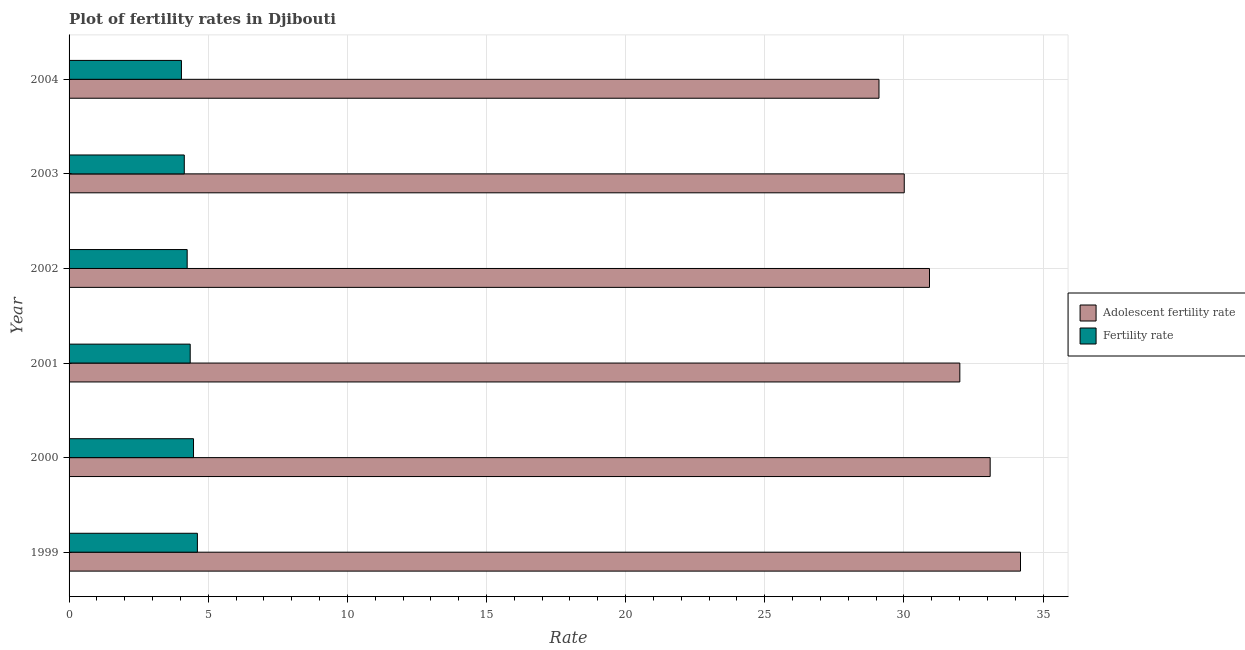How many groups of bars are there?
Keep it short and to the point. 6. Are the number of bars on each tick of the Y-axis equal?
Your answer should be compact. Yes. How many bars are there on the 6th tick from the top?
Provide a succinct answer. 2. In how many cases, is the number of bars for a given year not equal to the number of legend labels?
Offer a very short reply. 0. What is the adolescent fertility rate in 2001?
Ensure brevity in your answer.  32.01. Across all years, what is the maximum adolescent fertility rate?
Offer a terse response. 34.19. Across all years, what is the minimum fertility rate?
Your answer should be very brief. 4.04. What is the total adolescent fertility rate in the graph?
Ensure brevity in your answer.  189.33. What is the difference between the adolescent fertility rate in 2003 and that in 2004?
Offer a very short reply. 0.91. What is the difference between the adolescent fertility rate in 2002 and the fertility rate in 2003?
Your answer should be compact. 26.78. What is the average fertility rate per year?
Provide a succinct answer. 4.31. In the year 2000, what is the difference between the fertility rate and adolescent fertility rate?
Your response must be concise. -28.63. In how many years, is the fertility rate greater than 18 ?
Keep it short and to the point. 0. What is the ratio of the adolescent fertility rate in 1999 to that in 2004?
Offer a terse response. 1.18. Is the adolescent fertility rate in 2000 less than that in 2002?
Offer a terse response. No. Is the difference between the fertility rate in 2001 and 2003 greater than the difference between the adolescent fertility rate in 2001 and 2003?
Make the answer very short. No. What is the difference between the highest and the second highest adolescent fertility rate?
Provide a succinct answer. 1.09. What is the difference between the highest and the lowest adolescent fertility rate?
Offer a terse response. 5.09. In how many years, is the fertility rate greater than the average fertility rate taken over all years?
Keep it short and to the point. 3. What does the 1st bar from the top in 2000 represents?
Keep it short and to the point. Fertility rate. What does the 1st bar from the bottom in 2004 represents?
Keep it short and to the point. Adolescent fertility rate. Are all the bars in the graph horizontal?
Offer a terse response. Yes. What is the difference between two consecutive major ticks on the X-axis?
Offer a terse response. 5. Are the values on the major ticks of X-axis written in scientific E-notation?
Provide a succinct answer. No. Does the graph contain any zero values?
Your answer should be very brief. No. How are the legend labels stacked?
Provide a short and direct response. Vertical. What is the title of the graph?
Provide a short and direct response. Plot of fertility rates in Djibouti. Does "Male" appear as one of the legend labels in the graph?
Provide a short and direct response. No. What is the label or title of the X-axis?
Provide a succinct answer. Rate. What is the label or title of the Y-axis?
Keep it short and to the point. Year. What is the Rate of Adolescent fertility rate in 1999?
Your answer should be compact. 34.19. What is the Rate in Fertility rate in 1999?
Give a very brief answer. 4.61. What is the Rate of Adolescent fertility rate in 2000?
Your response must be concise. 33.1. What is the Rate of Fertility rate in 2000?
Make the answer very short. 4.47. What is the Rate in Adolescent fertility rate in 2001?
Offer a very short reply. 32.01. What is the Rate of Fertility rate in 2001?
Your answer should be very brief. 4.35. What is the Rate of Adolescent fertility rate in 2002?
Make the answer very short. 30.92. What is the Rate of Fertility rate in 2002?
Your response must be concise. 4.24. What is the Rate of Adolescent fertility rate in 2003?
Provide a short and direct response. 30.01. What is the Rate in Fertility rate in 2003?
Offer a terse response. 4.14. What is the Rate in Adolescent fertility rate in 2004?
Make the answer very short. 29.1. What is the Rate of Fertility rate in 2004?
Offer a very short reply. 4.04. Across all years, what is the maximum Rate of Adolescent fertility rate?
Offer a terse response. 34.19. Across all years, what is the maximum Rate in Fertility rate?
Your response must be concise. 4.61. Across all years, what is the minimum Rate in Adolescent fertility rate?
Offer a terse response. 29.1. Across all years, what is the minimum Rate of Fertility rate?
Provide a succinct answer. 4.04. What is the total Rate in Adolescent fertility rate in the graph?
Offer a terse response. 189.33. What is the total Rate of Fertility rate in the graph?
Make the answer very short. 25.86. What is the difference between the Rate in Adolescent fertility rate in 1999 and that in 2000?
Ensure brevity in your answer.  1.09. What is the difference between the Rate of Fertility rate in 1999 and that in 2000?
Offer a very short reply. 0.14. What is the difference between the Rate in Adolescent fertility rate in 1999 and that in 2001?
Offer a terse response. 2.18. What is the difference between the Rate in Fertility rate in 1999 and that in 2001?
Make the answer very short. 0.26. What is the difference between the Rate of Adolescent fertility rate in 1999 and that in 2002?
Ensure brevity in your answer.  3.27. What is the difference between the Rate in Fertility rate in 1999 and that in 2002?
Keep it short and to the point. 0.37. What is the difference between the Rate of Adolescent fertility rate in 1999 and that in 2003?
Ensure brevity in your answer.  4.18. What is the difference between the Rate in Fertility rate in 1999 and that in 2003?
Ensure brevity in your answer.  0.47. What is the difference between the Rate of Adolescent fertility rate in 1999 and that in 2004?
Keep it short and to the point. 5.09. What is the difference between the Rate in Fertility rate in 1999 and that in 2004?
Offer a very short reply. 0.57. What is the difference between the Rate of Adolescent fertility rate in 2000 and that in 2001?
Your response must be concise. 1.09. What is the difference between the Rate of Fertility rate in 2000 and that in 2001?
Your response must be concise. 0.12. What is the difference between the Rate in Adolescent fertility rate in 2000 and that in 2002?
Your response must be concise. 2.18. What is the difference between the Rate of Fertility rate in 2000 and that in 2002?
Your answer should be very brief. 0.23. What is the difference between the Rate in Adolescent fertility rate in 2000 and that in 2003?
Make the answer very short. 3.09. What is the difference between the Rate of Fertility rate in 2000 and that in 2003?
Provide a short and direct response. 0.33. What is the difference between the Rate of Adolescent fertility rate in 2000 and that in 2004?
Your answer should be very brief. 4. What is the difference between the Rate in Fertility rate in 2000 and that in 2004?
Make the answer very short. 0.43. What is the difference between the Rate of Adolescent fertility rate in 2001 and that in 2002?
Your answer should be very brief. 1.09. What is the difference between the Rate of Fertility rate in 2001 and that in 2002?
Offer a terse response. 0.11. What is the difference between the Rate of Adolescent fertility rate in 2001 and that in 2003?
Your answer should be very brief. 2. What is the difference between the Rate of Fertility rate in 2001 and that in 2003?
Offer a terse response. 0.21. What is the difference between the Rate of Adolescent fertility rate in 2001 and that in 2004?
Your answer should be very brief. 2.91. What is the difference between the Rate in Fertility rate in 2001 and that in 2004?
Offer a terse response. 0.32. What is the difference between the Rate of Adolescent fertility rate in 2002 and that in 2003?
Offer a terse response. 0.91. What is the difference between the Rate of Fertility rate in 2002 and that in 2003?
Make the answer very short. 0.1. What is the difference between the Rate in Adolescent fertility rate in 2002 and that in 2004?
Provide a succinct answer. 1.82. What is the difference between the Rate in Fertility rate in 2002 and that in 2004?
Provide a short and direct response. 0.21. What is the difference between the Rate of Adolescent fertility rate in 2003 and that in 2004?
Your response must be concise. 0.91. What is the difference between the Rate in Fertility rate in 2003 and that in 2004?
Your response must be concise. 0.1. What is the difference between the Rate in Adolescent fertility rate in 1999 and the Rate in Fertility rate in 2000?
Offer a very short reply. 29.72. What is the difference between the Rate in Adolescent fertility rate in 1999 and the Rate in Fertility rate in 2001?
Offer a very short reply. 29.84. What is the difference between the Rate in Adolescent fertility rate in 1999 and the Rate in Fertility rate in 2002?
Keep it short and to the point. 29.95. What is the difference between the Rate of Adolescent fertility rate in 1999 and the Rate of Fertility rate in 2003?
Ensure brevity in your answer.  30.05. What is the difference between the Rate in Adolescent fertility rate in 1999 and the Rate in Fertility rate in 2004?
Provide a short and direct response. 30.15. What is the difference between the Rate of Adolescent fertility rate in 2000 and the Rate of Fertility rate in 2001?
Provide a succinct answer. 28.75. What is the difference between the Rate in Adolescent fertility rate in 2000 and the Rate in Fertility rate in 2002?
Ensure brevity in your answer.  28.86. What is the difference between the Rate of Adolescent fertility rate in 2000 and the Rate of Fertility rate in 2003?
Your response must be concise. 28.96. What is the difference between the Rate of Adolescent fertility rate in 2000 and the Rate of Fertility rate in 2004?
Ensure brevity in your answer.  29.06. What is the difference between the Rate of Adolescent fertility rate in 2001 and the Rate of Fertility rate in 2002?
Keep it short and to the point. 27.77. What is the difference between the Rate of Adolescent fertility rate in 2001 and the Rate of Fertility rate in 2003?
Ensure brevity in your answer.  27.87. What is the difference between the Rate of Adolescent fertility rate in 2001 and the Rate of Fertility rate in 2004?
Your response must be concise. 27.97. What is the difference between the Rate of Adolescent fertility rate in 2002 and the Rate of Fertility rate in 2003?
Keep it short and to the point. 26.78. What is the difference between the Rate in Adolescent fertility rate in 2002 and the Rate in Fertility rate in 2004?
Provide a short and direct response. 26.88. What is the difference between the Rate of Adolescent fertility rate in 2003 and the Rate of Fertility rate in 2004?
Ensure brevity in your answer.  25.97. What is the average Rate of Adolescent fertility rate per year?
Provide a succinct answer. 31.56. What is the average Rate of Fertility rate per year?
Your answer should be very brief. 4.31. In the year 1999, what is the difference between the Rate of Adolescent fertility rate and Rate of Fertility rate?
Provide a short and direct response. 29.58. In the year 2000, what is the difference between the Rate of Adolescent fertility rate and Rate of Fertility rate?
Provide a short and direct response. 28.63. In the year 2001, what is the difference between the Rate of Adolescent fertility rate and Rate of Fertility rate?
Provide a succinct answer. 27.66. In the year 2002, what is the difference between the Rate of Adolescent fertility rate and Rate of Fertility rate?
Provide a succinct answer. 26.68. In the year 2003, what is the difference between the Rate of Adolescent fertility rate and Rate of Fertility rate?
Give a very brief answer. 25.87. In the year 2004, what is the difference between the Rate in Adolescent fertility rate and Rate in Fertility rate?
Offer a very short reply. 25.07. What is the ratio of the Rate in Adolescent fertility rate in 1999 to that in 2000?
Ensure brevity in your answer.  1.03. What is the ratio of the Rate of Fertility rate in 1999 to that in 2000?
Provide a succinct answer. 1.03. What is the ratio of the Rate in Adolescent fertility rate in 1999 to that in 2001?
Offer a very short reply. 1.07. What is the ratio of the Rate in Fertility rate in 1999 to that in 2001?
Your answer should be compact. 1.06. What is the ratio of the Rate of Adolescent fertility rate in 1999 to that in 2002?
Your response must be concise. 1.11. What is the ratio of the Rate in Fertility rate in 1999 to that in 2002?
Keep it short and to the point. 1.09. What is the ratio of the Rate of Adolescent fertility rate in 1999 to that in 2003?
Give a very brief answer. 1.14. What is the ratio of the Rate in Fertility rate in 1999 to that in 2003?
Ensure brevity in your answer.  1.11. What is the ratio of the Rate in Adolescent fertility rate in 1999 to that in 2004?
Offer a terse response. 1.17. What is the ratio of the Rate in Fertility rate in 1999 to that in 2004?
Keep it short and to the point. 1.14. What is the ratio of the Rate in Adolescent fertility rate in 2000 to that in 2001?
Your response must be concise. 1.03. What is the ratio of the Rate in Fertility rate in 2000 to that in 2001?
Ensure brevity in your answer.  1.03. What is the ratio of the Rate in Adolescent fertility rate in 2000 to that in 2002?
Keep it short and to the point. 1.07. What is the ratio of the Rate of Fertility rate in 2000 to that in 2002?
Provide a succinct answer. 1.05. What is the ratio of the Rate of Adolescent fertility rate in 2000 to that in 2003?
Your answer should be very brief. 1.1. What is the ratio of the Rate of Fertility rate in 2000 to that in 2003?
Ensure brevity in your answer.  1.08. What is the ratio of the Rate in Adolescent fertility rate in 2000 to that in 2004?
Give a very brief answer. 1.14. What is the ratio of the Rate of Fertility rate in 2000 to that in 2004?
Keep it short and to the point. 1.11. What is the ratio of the Rate of Adolescent fertility rate in 2001 to that in 2002?
Ensure brevity in your answer.  1.04. What is the ratio of the Rate of Fertility rate in 2001 to that in 2002?
Provide a short and direct response. 1.03. What is the ratio of the Rate of Adolescent fertility rate in 2001 to that in 2003?
Keep it short and to the point. 1.07. What is the ratio of the Rate in Fertility rate in 2001 to that in 2003?
Make the answer very short. 1.05. What is the ratio of the Rate of Adolescent fertility rate in 2001 to that in 2004?
Offer a very short reply. 1.1. What is the ratio of the Rate in Fertility rate in 2001 to that in 2004?
Ensure brevity in your answer.  1.08. What is the ratio of the Rate of Adolescent fertility rate in 2002 to that in 2003?
Give a very brief answer. 1.03. What is the ratio of the Rate in Fertility rate in 2002 to that in 2003?
Make the answer very short. 1.03. What is the ratio of the Rate of Adolescent fertility rate in 2002 to that in 2004?
Provide a short and direct response. 1.06. What is the ratio of the Rate of Fertility rate in 2002 to that in 2004?
Provide a succinct answer. 1.05. What is the ratio of the Rate in Adolescent fertility rate in 2003 to that in 2004?
Keep it short and to the point. 1.03. What is the ratio of the Rate of Fertility rate in 2003 to that in 2004?
Your response must be concise. 1.03. What is the difference between the highest and the second highest Rate of Adolescent fertility rate?
Your answer should be compact. 1.09. What is the difference between the highest and the second highest Rate in Fertility rate?
Offer a terse response. 0.14. What is the difference between the highest and the lowest Rate of Adolescent fertility rate?
Ensure brevity in your answer.  5.09. What is the difference between the highest and the lowest Rate of Fertility rate?
Ensure brevity in your answer.  0.57. 